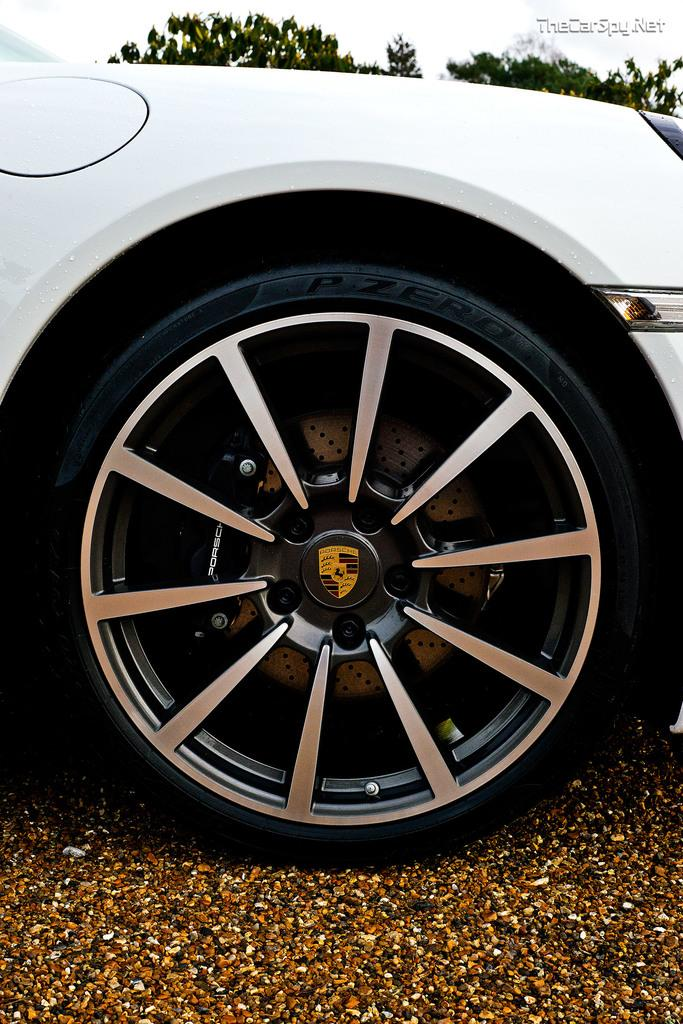What type of vehicle is partially covered in the image? The image shows a partially covered vehicle, but the specific type cannot be determined from the facts provided. What can be seen beneath the vehicle cover? The ground is visible in the image. What type of natural environment is present in the image? There are trees and the sky visible in the image, indicating a natural setting. What is written or displayed on the top right side of the image? There is some text on the top right side of the image, but the content cannot be determined from the facts provided. What type of substance is being used to write in the notebook in the image? There is no notebook present in the image, so it is not possible to determine what type of substance might be used for writing. 